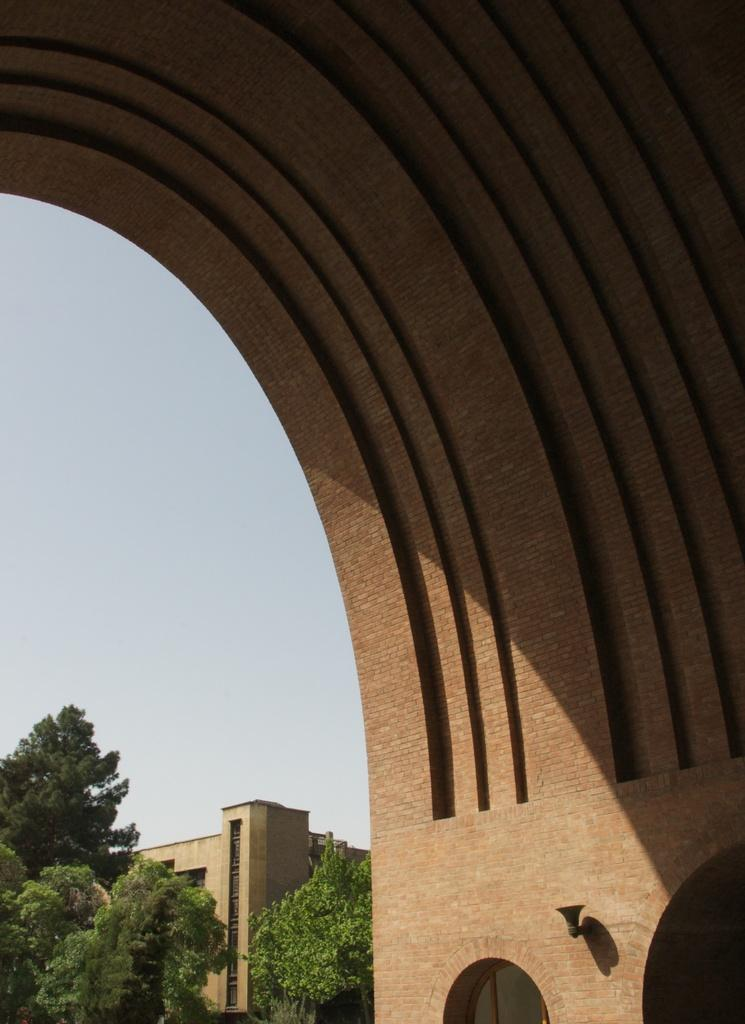What type of structure is present in the image? There is an arch made up of bricks in the image. What can be seen in the background of the image? There is a building and trees in the background of the image. What type of crib is visible in the image? There is no crib present in the image. What wish can be granted by looking at the image? There is no wish-granting element in the image. 